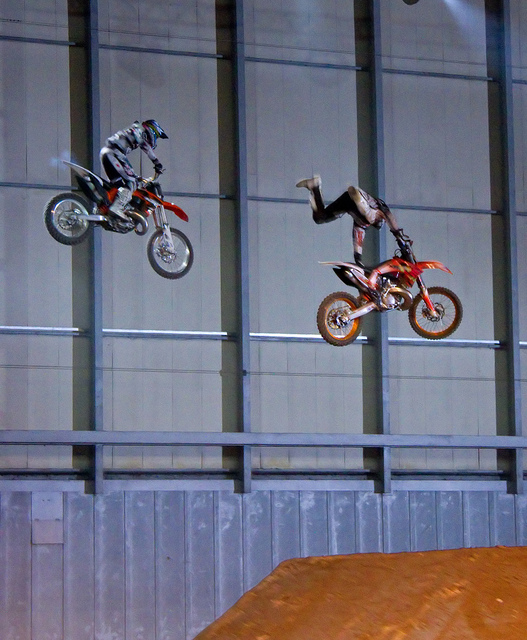What kind of event might this image depict? The image likely depicts a motocross or motorcycle stunt event, where riders perform aerial tricks and maneuvers on dirt bikes. 